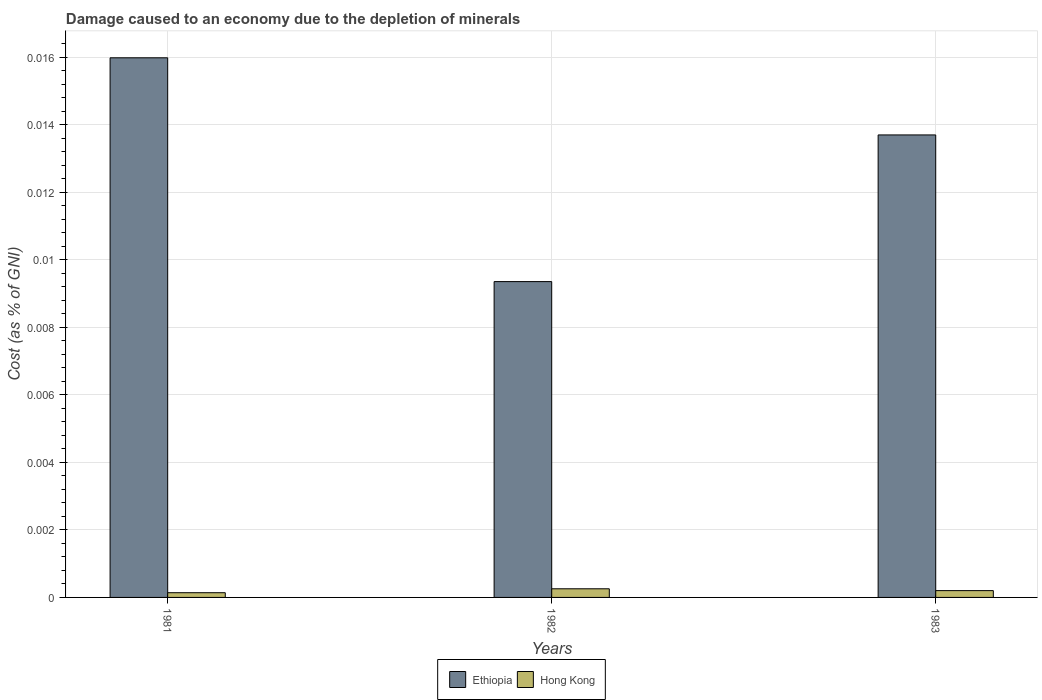How many different coloured bars are there?
Keep it short and to the point. 2. How many groups of bars are there?
Offer a terse response. 3. Are the number of bars on each tick of the X-axis equal?
Provide a succinct answer. Yes. How many bars are there on the 1st tick from the left?
Ensure brevity in your answer.  2. What is the label of the 1st group of bars from the left?
Offer a terse response. 1981. In how many cases, is the number of bars for a given year not equal to the number of legend labels?
Keep it short and to the point. 0. What is the cost of damage caused due to the depletion of minerals in Hong Kong in 1983?
Make the answer very short. 0. Across all years, what is the maximum cost of damage caused due to the depletion of minerals in Ethiopia?
Offer a terse response. 0.02. Across all years, what is the minimum cost of damage caused due to the depletion of minerals in Ethiopia?
Offer a very short reply. 0.01. In which year was the cost of damage caused due to the depletion of minerals in Ethiopia maximum?
Your answer should be compact. 1981. What is the total cost of damage caused due to the depletion of minerals in Ethiopia in the graph?
Make the answer very short. 0.04. What is the difference between the cost of damage caused due to the depletion of minerals in Ethiopia in 1981 and that in 1982?
Ensure brevity in your answer.  0.01. What is the difference between the cost of damage caused due to the depletion of minerals in Hong Kong in 1982 and the cost of damage caused due to the depletion of minerals in Ethiopia in 1983?
Give a very brief answer. -0.01. What is the average cost of damage caused due to the depletion of minerals in Hong Kong per year?
Make the answer very short. 0. In the year 1982, what is the difference between the cost of damage caused due to the depletion of minerals in Hong Kong and cost of damage caused due to the depletion of minerals in Ethiopia?
Ensure brevity in your answer.  -0.01. In how many years, is the cost of damage caused due to the depletion of minerals in Ethiopia greater than 0.0072 %?
Make the answer very short. 3. What is the ratio of the cost of damage caused due to the depletion of minerals in Ethiopia in 1981 to that in 1983?
Your answer should be very brief. 1.17. Is the cost of damage caused due to the depletion of minerals in Hong Kong in 1981 less than that in 1982?
Keep it short and to the point. Yes. Is the difference between the cost of damage caused due to the depletion of minerals in Hong Kong in 1981 and 1983 greater than the difference between the cost of damage caused due to the depletion of minerals in Ethiopia in 1981 and 1983?
Offer a very short reply. No. What is the difference between the highest and the second highest cost of damage caused due to the depletion of minerals in Ethiopia?
Your answer should be very brief. 0. What is the difference between the highest and the lowest cost of damage caused due to the depletion of minerals in Ethiopia?
Give a very brief answer. 0.01. What does the 1st bar from the left in 1983 represents?
Offer a terse response. Ethiopia. What does the 1st bar from the right in 1983 represents?
Your answer should be very brief. Hong Kong. How many years are there in the graph?
Your answer should be compact. 3. What is the difference between two consecutive major ticks on the Y-axis?
Make the answer very short. 0. Does the graph contain grids?
Offer a very short reply. Yes. How many legend labels are there?
Provide a short and direct response. 2. What is the title of the graph?
Provide a short and direct response. Damage caused to an economy due to the depletion of minerals. Does "Mozambique" appear as one of the legend labels in the graph?
Ensure brevity in your answer.  No. What is the label or title of the X-axis?
Provide a short and direct response. Years. What is the label or title of the Y-axis?
Ensure brevity in your answer.  Cost (as % of GNI). What is the Cost (as % of GNI) of Ethiopia in 1981?
Keep it short and to the point. 0.02. What is the Cost (as % of GNI) in Hong Kong in 1981?
Give a very brief answer. 0. What is the Cost (as % of GNI) of Ethiopia in 1982?
Ensure brevity in your answer.  0.01. What is the Cost (as % of GNI) in Hong Kong in 1982?
Offer a terse response. 0. What is the Cost (as % of GNI) in Ethiopia in 1983?
Ensure brevity in your answer.  0.01. What is the Cost (as % of GNI) in Hong Kong in 1983?
Your answer should be very brief. 0. Across all years, what is the maximum Cost (as % of GNI) in Ethiopia?
Give a very brief answer. 0.02. Across all years, what is the maximum Cost (as % of GNI) in Hong Kong?
Your answer should be compact. 0. Across all years, what is the minimum Cost (as % of GNI) in Ethiopia?
Your response must be concise. 0.01. Across all years, what is the minimum Cost (as % of GNI) in Hong Kong?
Your answer should be compact. 0. What is the total Cost (as % of GNI) in Ethiopia in the graph?
Provide a short and direct response. 0.04. What is the total Cost (as % of GNI) in Hong Kong in the graph?
Provide a succinct answer. 0. What is the difference between the Cost (as % of GNI) of Ethiopia in 1981 and that in 1982?
Provide a short and direct response. 0.01. What is the difference between the Cost (as % of GNI) in Hong Kong in 1981 and that in 1982?
Make the answer very short. -0. What is the difference between the Cost (as % of GNI) in Ethiopia in 1981 and that in 1983?
Your response must be concise. 0. What is the difference between the Cost (as % of GNI) of Hong Kong in 1981 and that in 1983?
Offer a very short reply. -0. What is the difference between the Cost (as % of GNI) in Ethiopia in 1982 and that in 1983?
Offer a terse response. -0. What is the difference between the Cost (as % of GNI) of Ethiopia in 1981 and the Cost (as % of GNI) of Hong Kong in 1982?
Keep it short and to the point. 0.02. What is the difference between the Cost (as % of GNI) in Ethiopia in 1981 and the Cost (as % of GNI) in Hong Kong in 1983?
Your answer should be compact. 0.02. What is the difference between the Cost (as % of GNI) in Ethiopia in 1982 and the Cost (as % of GNI) in Hong Kong in 1983?
Your answer should be compact. 0.01. What is the average Cost (as % of GNI) in Ethiopia per year?
Your response must be concise. 0.01. In the year 1981, what is the difference between the Cost (as % of GNI) in Ethiopia and Cost (as % of GNI) in Hong Kong?
Offer a terse response. 0.02. In the year 1982, what is the difference between the Cost (as % of GNI) in Ethiopia and Cost (as % of GNI) in Hong Kong?
Offer a terse response. 0.01. In the year 1983, what is the difference between the Cost (as % of GNI) in Ethiopia and Cost (as % of GNI) in Hong Kong?
Provide a short and direct response. 0.01. What is the ratio of the Cost (as % of GNI) of Ethiopia in 1981 to that in 1982?
Make the answer very short. 1.71. What is the ratio of the Cost (as % of GNI) of Hong Kong in 1981 to that in 1982?
Provide a succinct answer. 0.54. What is the ratio of the Cost (as % of GNI) of Ethiopia in 1981 to that in 1983?
Your response must be concise. 1.17. What is the ratio of the Cost (as % of GNI) in Hong Kong in 1981 to that in 1983?
Make the answer very short. 0.69. What is the ratio of the Cost (as % of GNI) in Ethiopia in 1982 to that in 1983?
Ensure brevity in your answer.  0.68. What is the ratio of the Cost (as % of GNI) in Hong Kong in 1982 to that in 1983?
Offer a very short reply. 1.27. What is the difference between the highest and the second highest Cost (as % of GNI) of Ethiopia?
Offer a very short reply. 0. What is the difference between the highest and the second highest Cost (as % of GNI) of Hong Kong?
Your response must be concise. 0. What is the difference between the highest and the lowest Cost (as % of GNI) of Ethiopia?
Your answer should be compact. 0.01. What is the difference between the highest and the lowest Cost (as % of GNI) of Hong Kong?
Keep it short and to the point. 0. 